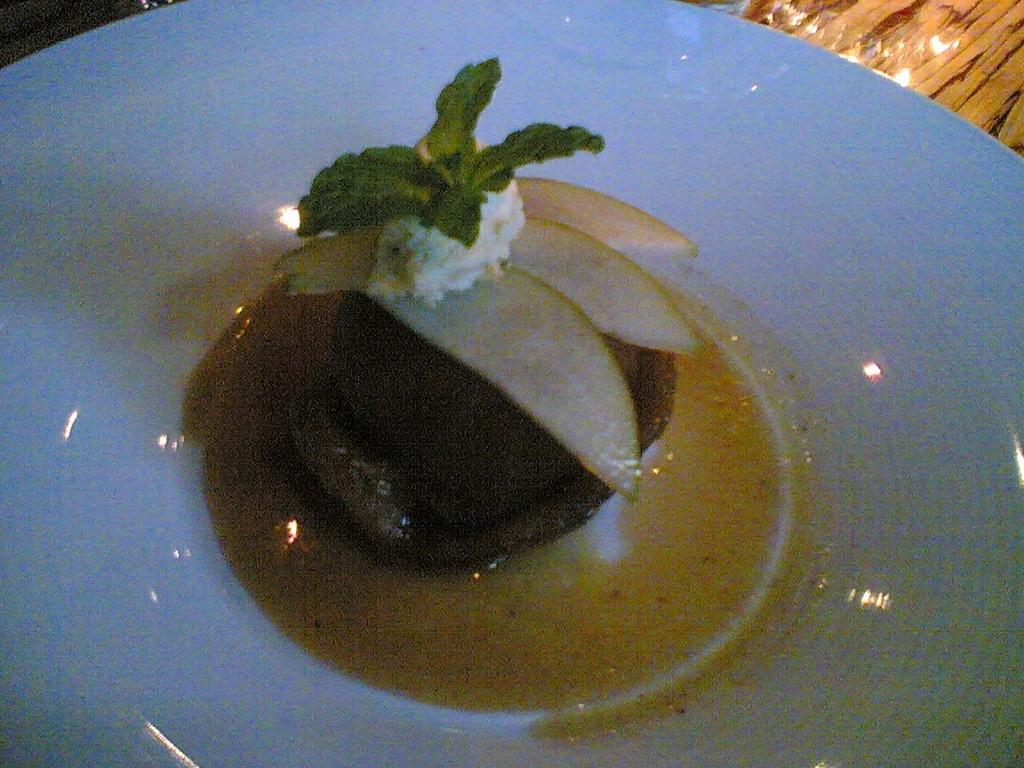What color is the plate that is visible in the image? The plate is white. What is on the plate in the image? There is food on the plate. What can be seen on the surface of the plate due to the lighting? The reflection of lights is visible on the plate. What letters can be seen on the plate in the image? There are no letters visible on the plate in the image. What type of orange fruit is present on the plate in the image? There is no orange fruit present on the plate in the image. 